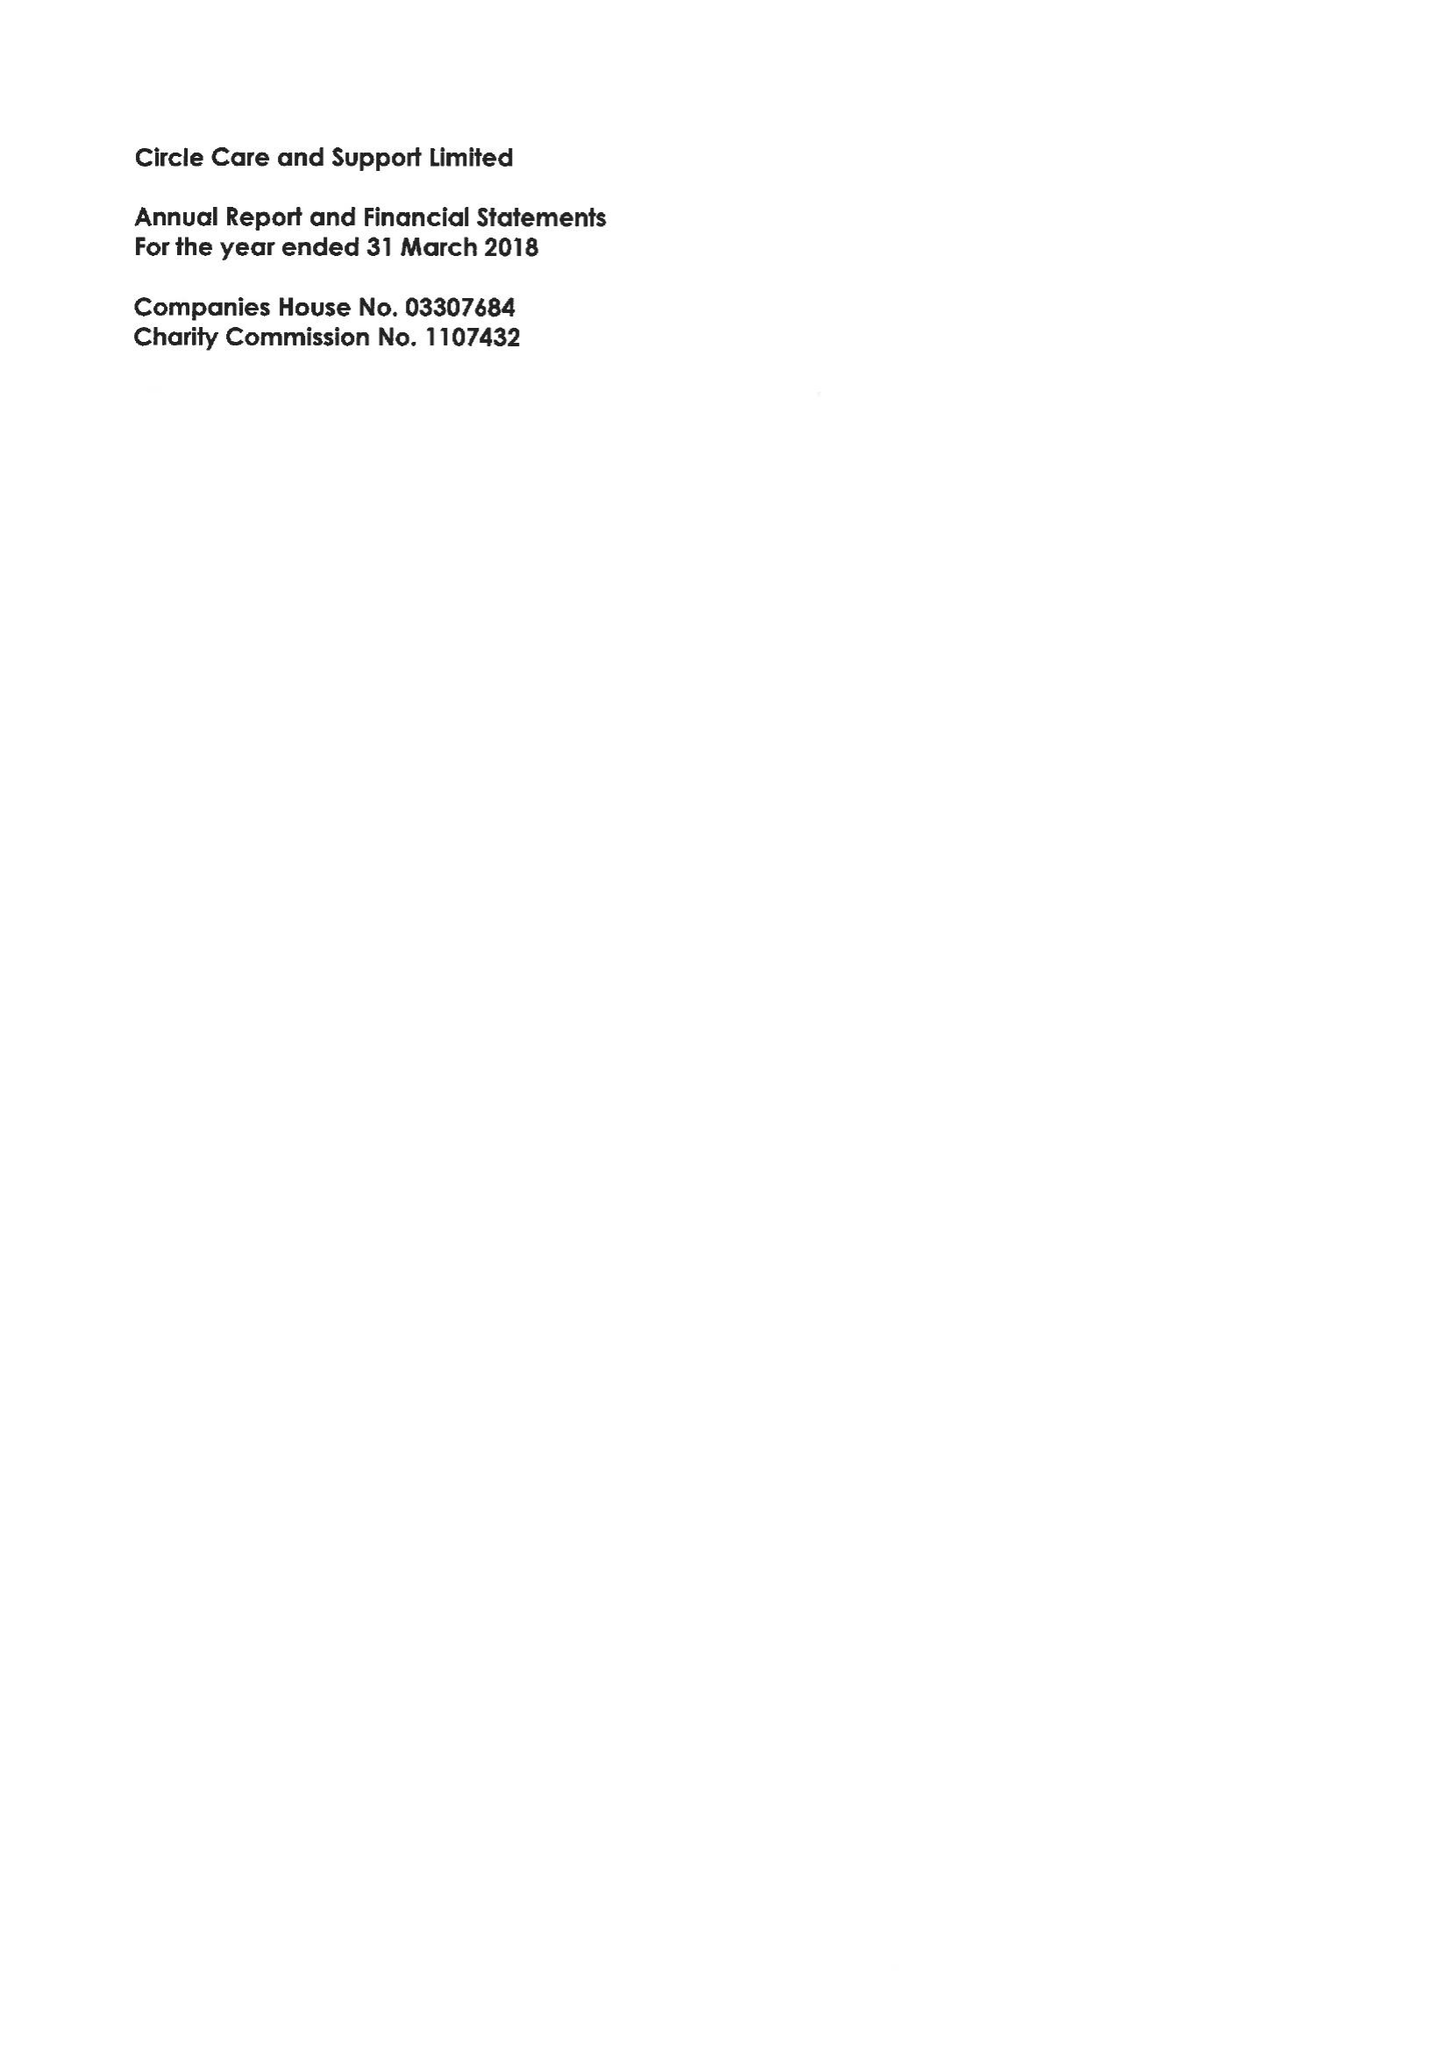What is the value for the report_date?
Answer the question using a single word or phrase. 2018-03-31 